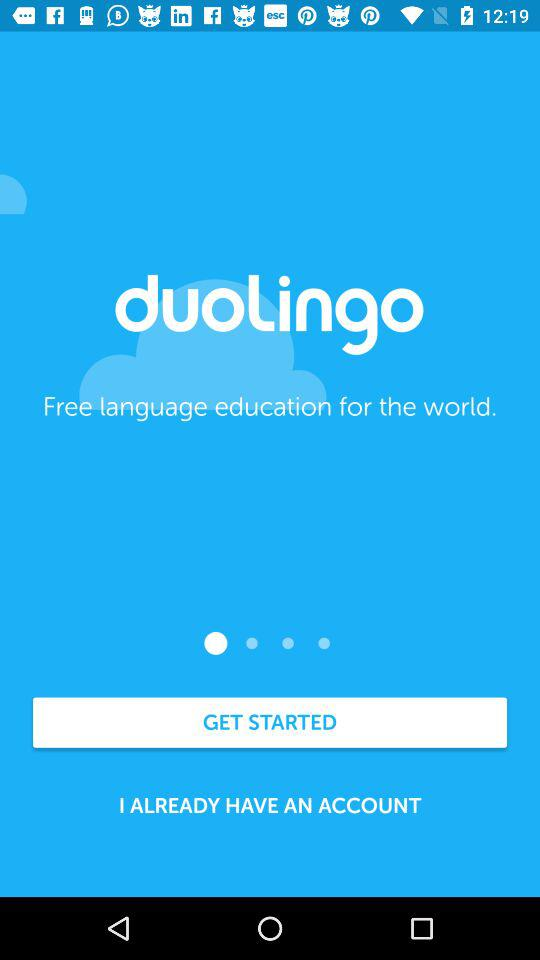What is the application name? The application name is "duolingo". 